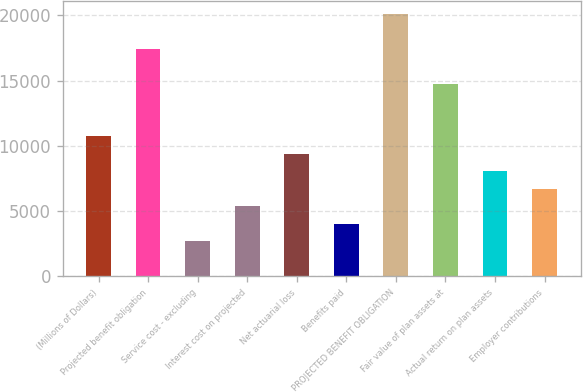Convert chart to OTSL. <chart><loc_0><loc_0><loc_500><loc_500><bar_chart><fcel>(Millions of Dollars)<fcel>Projected benefit obligation<fcel>Service cost - excluding<fcel>Interest cost on projected<fcel>Net actuarial loss<fcel>Benefits paid<fcel>PROJECTED BENEFIT OBLIGATION<fcel>Fair value of plan assets at<fcel>Actual return on plan assets<fcel>Employer contributions<nl><fcel>10729.4<fcel>17420.9<fcel>2699.6<fcel>5376.2<fcel>9391.1<fcel>4037.9<fcel>20097.5<fcel>14744.3<fcel>8052.8<fcel>6714.5<nl></chart> 